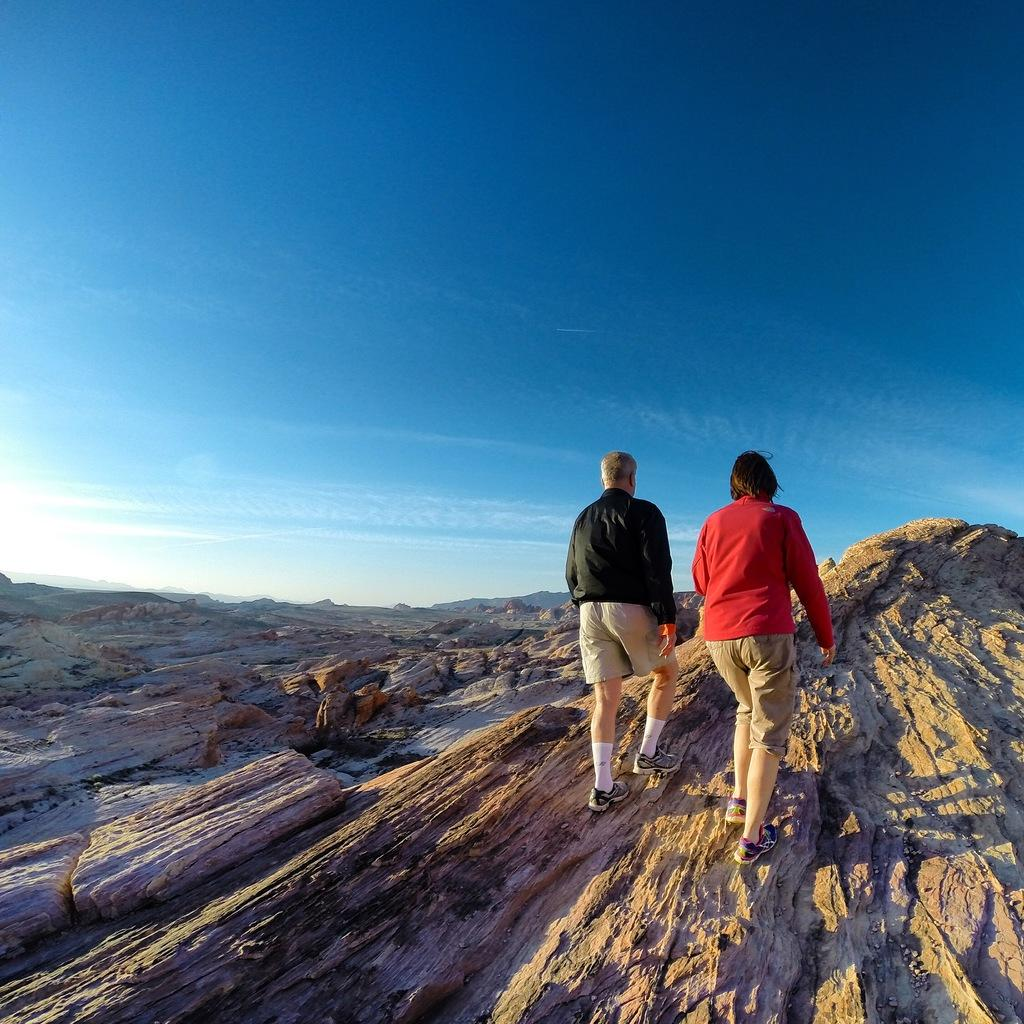What are the two people in the image doing? The two people in the image are walking. What can be seen in the background of the image? The sky, clouds, and hills are visible in the background of the image. What is the size of the cream on the hill in the image? There is no cream present in the image, and the hill is not associated with any cream. 